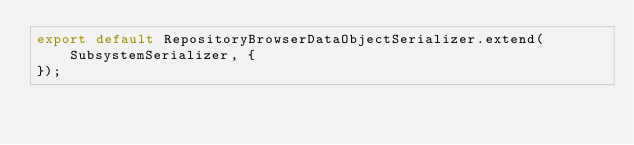Convert code to text. <code><loc_0><loc_0><loc_500><loc_500><_JavaScript_>export default RepositoryBrowserDataObjectSerializer.extend(SubsystemSerializer, {
});
</code> 